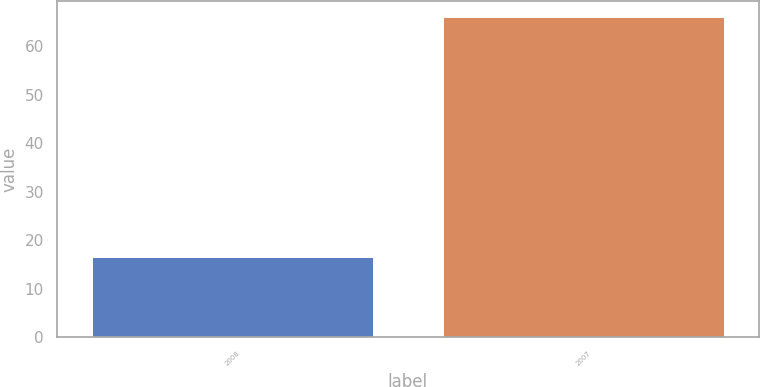<chart> <loc_0><loc_0><loc_500><loc_500><bar_chart><fcel>2008<fcel>2007<nl><fcel>16.5<fcel>66<nl></chart> 